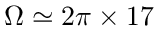Convert formula to latex. <formula><loc_0><loc_0><loc_500><loc_500>\Omega \simeq 2 \pi \times 1 7</formula> 